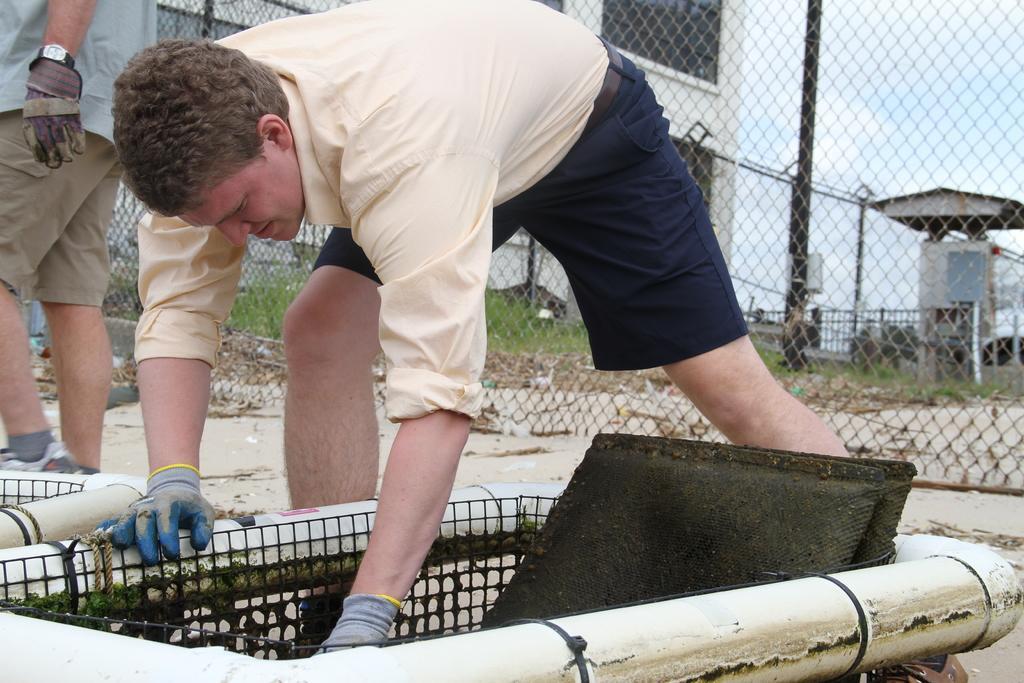Describe this image in one or two sentences. The man in cream shirt who is wearing gloves is doing something. Beside him, we see a man in grey T-shirt is standing. Behind him, we see a fence and beside that, we see a building and a pole. In the background, we see a railing. In the right top of the picture, we see the sky. 